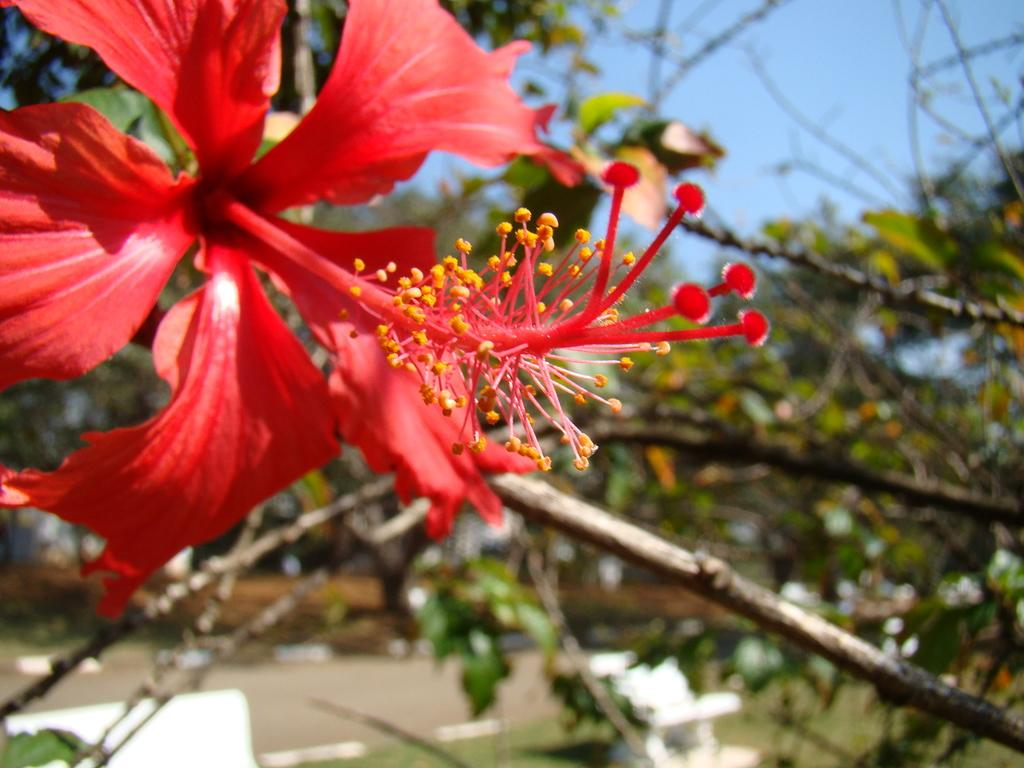What type of flower is in the image? There is a red hibiscus flower in the image. Where is the flower located? The flower is on a plant. Can you describe the background of the image? The background of the plant is blurred. How does the pollution affect the journey of the waves in the image? There is no reference to pollution, journey, or waves in the image, so it is not possible to answer that question. 